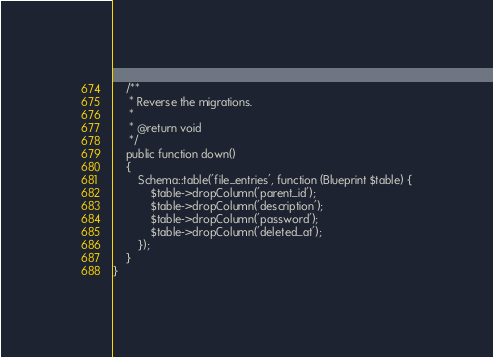<code> <loc_0><loc_0><loc_500><loc_500><_PHP_>
    /**
     * Reverse the migrations.
     *
     * @return void
     */
    public function down()
    {
        Schema::table('file_entries', function (Blueprint $table) {
            $table->dropColumn('parent_id');
            $table->dropColumn('description');
            $table->dropColumn('password');
            $table->dropColumn('deleted_at');
        });
    }
}
</code> 